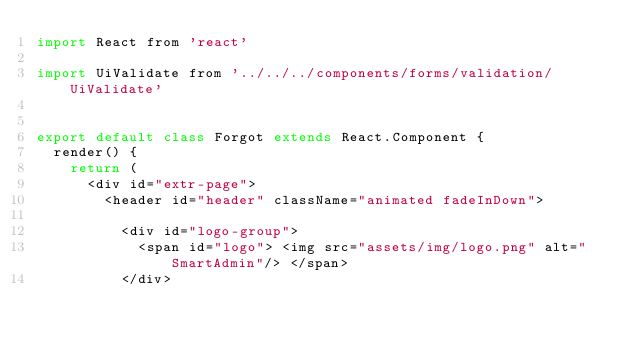<code> <loc_0><loc_0><loc_500><loc_500><_JavaScript_>import React from 'react'

import UiValidate from '../../../components/forms/validation/UiValidate'


export default class Forgot extends React.Component {
  render() {
    return (
      <div id="extr-page">
        <header id="header" className="animated fadeInDown">

          <div id="logo-group">
            <span id="logo"> <img src="assets/img/logo.png" alt="SmartAdmin"/> </span>
          </div>
</code> 